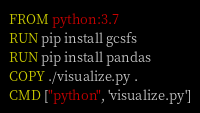Convert code to text. <code><loc_0><loc_0><loc_500><loc_500><_Dockerfile_>FROM python:3.7
RUN pip install gcsfs
RUN pip install pandas
COPY ./visualize.py .
CMD ["python", 'visualize.py']</code> 